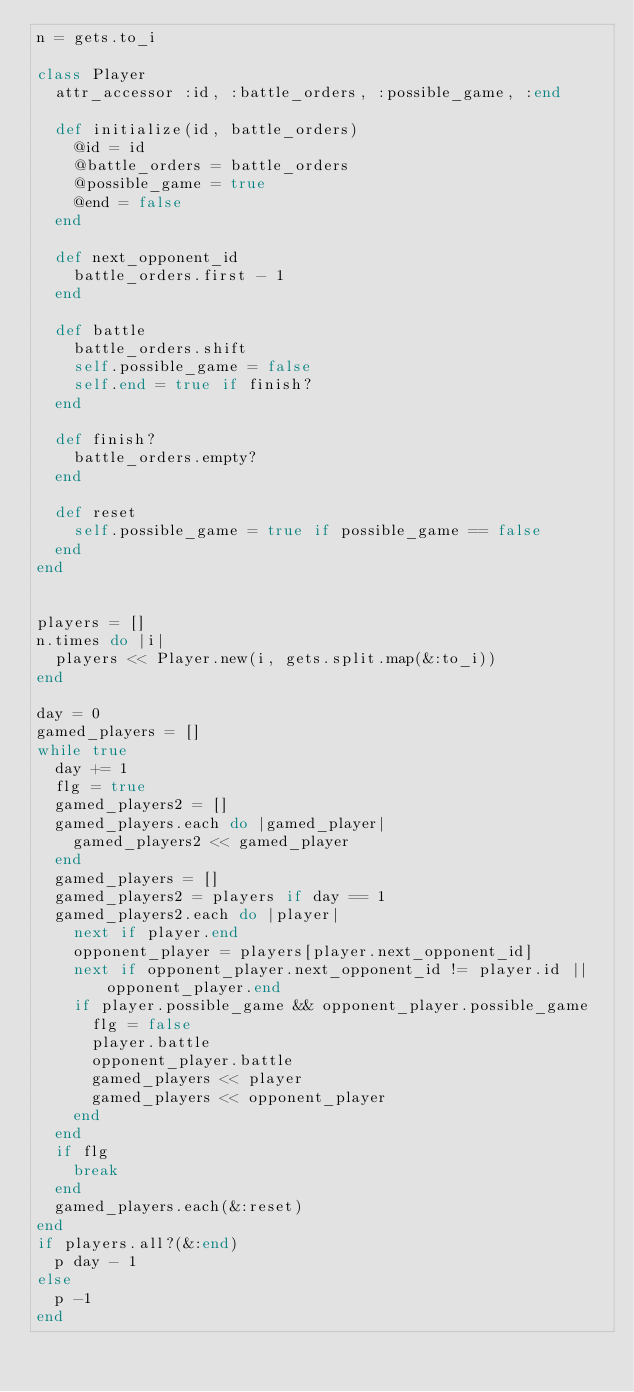<code> <loc_0><loc_0><loc_500><loc_500><_Ruby_>n = gets.to_i
 
class Player
  attr_accessor :id, :battle_orders, :possible_game, :end
 
  def initialize(id, battle_orders)
    @id = id
    @battle_orders = battle_orders
    @possible_game = true
    @end = false
  end
 
  def next_opponent_id
    battle_orders.first - 1
  end
 
  def battle
    battle_orders.shift
    self.possible_game = false
    self.end = true if finish?
  end
 
  def finish?
    battle_orders.empty?
  end
 
  def reset
    self.possible_game = true if possible_game == false
  end
end
 
 
players = []
n.times do |i|
  players << Player.new(i, gets.split.map(&:to_i))
end
 
day = 0
gamed_players = []
while true
  day += 1
  flg = true
  gamed_players2 = []
  gamed_players.each do |gamed_player|
    gamed_players2 << gamed_player
  end
  gamed_players = []
  gamed_players2 = players if day == 1
  gamed_players2.each do |player|
    next if player.end
    opponent_player = players[player.next_opponent_id]
    next if opponent_player.next_opponent_id != player.id || opponent_player.end
    if player.possible_game && opponent_player.possible_game
      flg = false
      player.battle
      opponent_player.battle
      gamed_players << player
      gamed_players << opponent_player
    end
  end
  if flg
    break
  end
  gamed_players.each(&:reset)
end
if players.all?(&:end)
  p day - 1
else
  p -1
end
</code> 